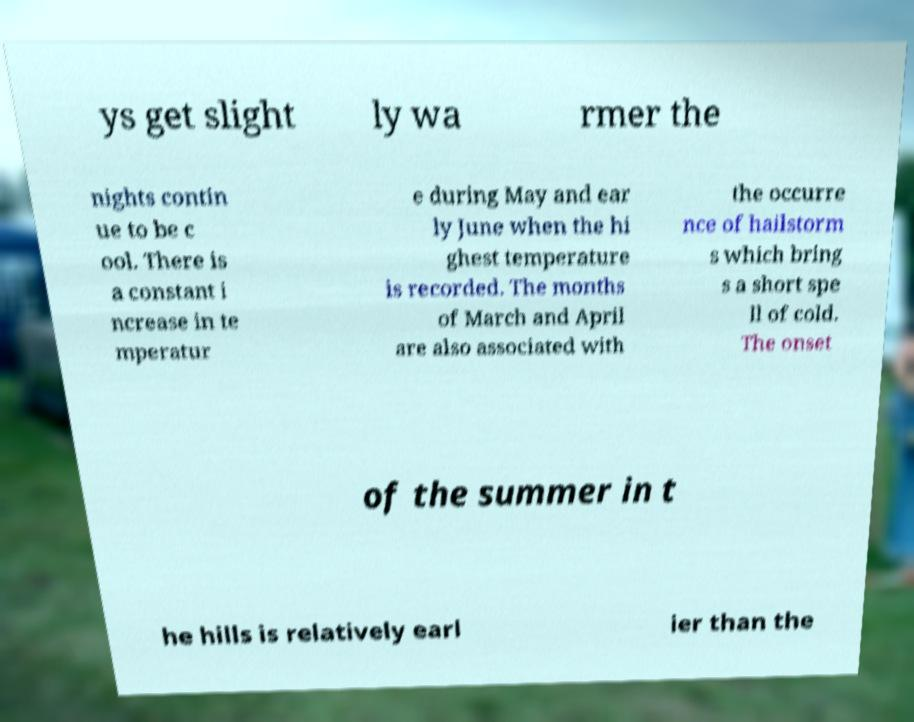Could you assist in decoding the text presented in this image and type it out clearly? ys get slight ly wa rmer the nights contin ue to be c ool. There is a constant i ncrease in te mperatur e during May and ear ly June when the hi ghest temperature is recorded. The months of March and April are also associated with the occurre nce of hailstorm s which bring s a short spe ll of cold. The onset of the summer in t he hills is relatively earl ier than the 